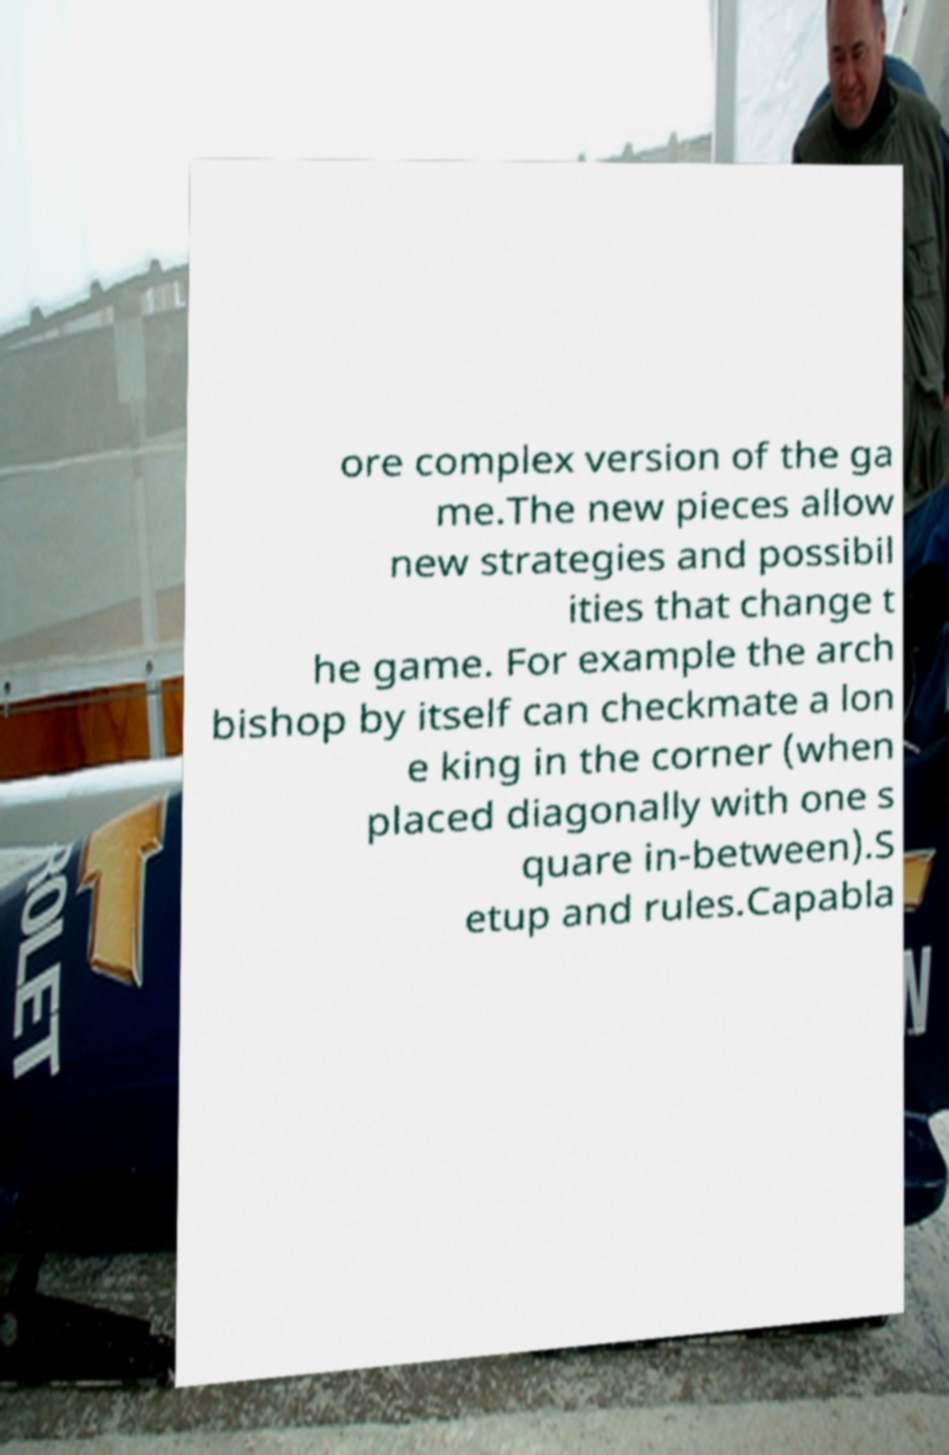Can you accurately transcribe the text from the provided image for me? ore complex version of the ga me.The new pieces allow new strategies and possibil ities that change t he game. For example the arch bishop by itself can checkmate a lon e king in the corner (when placed diagonally with one s quare in-between).S etup and rules.Capabla 